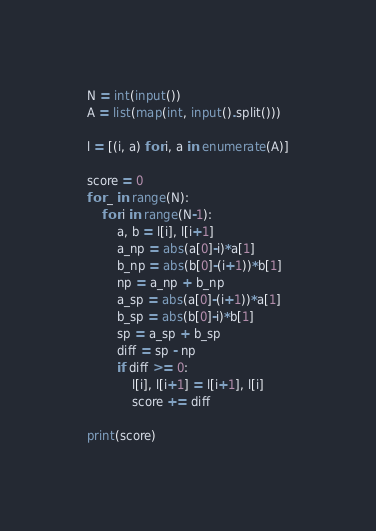Convert code to text. <code><loc_0><loc_0><loc_500><loc_500><_Python_>N = int(input())
A = list(map(int, input().split()))

l = [(i, a) for i, a in enumerate(A)]

score = 0
for _ in range(N):
    for i in range(N-1):
        a, b = l[i], l[i+1]
        a_np = abs(a[0]-i)*a[1]
        b_np = abs(b[0]-(i+1))*b[1]
        np = a_np + b_np
        a_sp = abs(a[0]-(i+1))*a[1]
        b_sp = abs(b[0]-i)*b[1]
        sp = a_sp + b_sp
        diff = sp - np
        if diff >= 0:
            l[i], l[i+1] = l[i+1], l[i]
            score += diff

print(score)</code> 